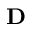<formula> <loc_0><loc_0><loc_500><loc_500>D</formula> 